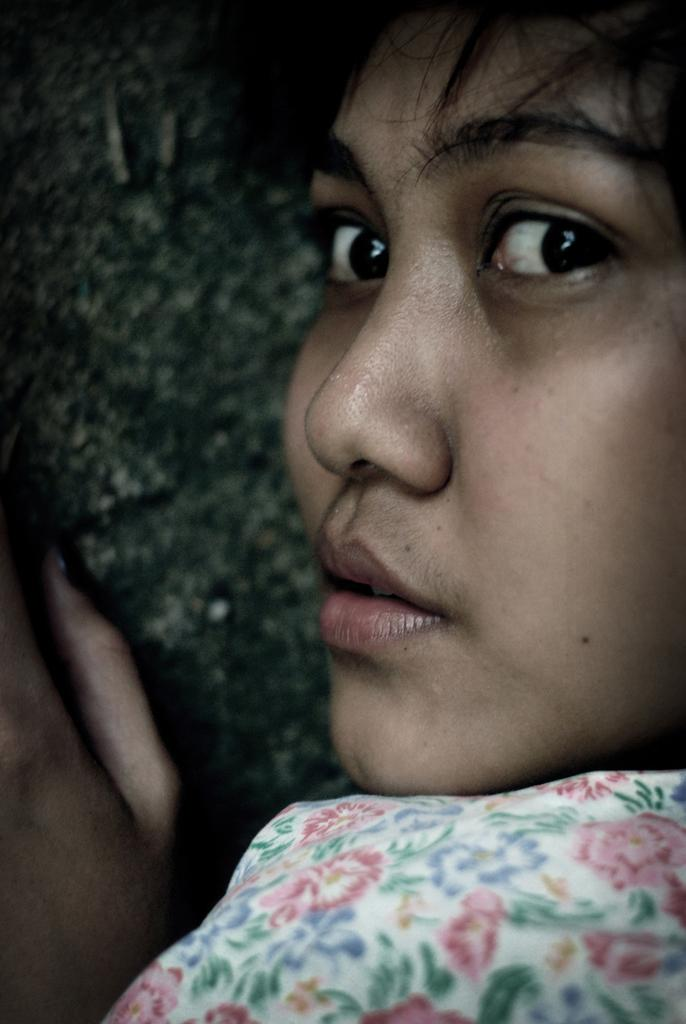Who is present in the image? There is a woman in the image. What can be seen in the background of the image? There is a wall in the background of the image. How many frogs are sitting on the woman's shoulder in the image? There are no frogs present in the image, so it is not possible to determine how many might be sitting on the woman's shoulder. 